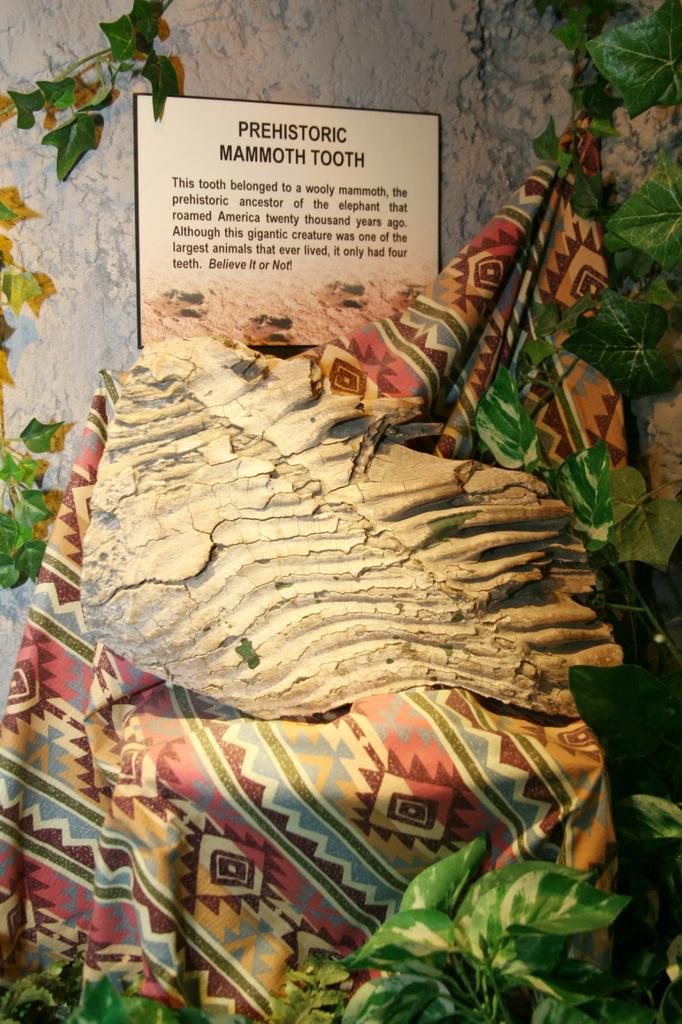Is the mammoth tooth prehistoric?
Make the answer very short. Yes. 